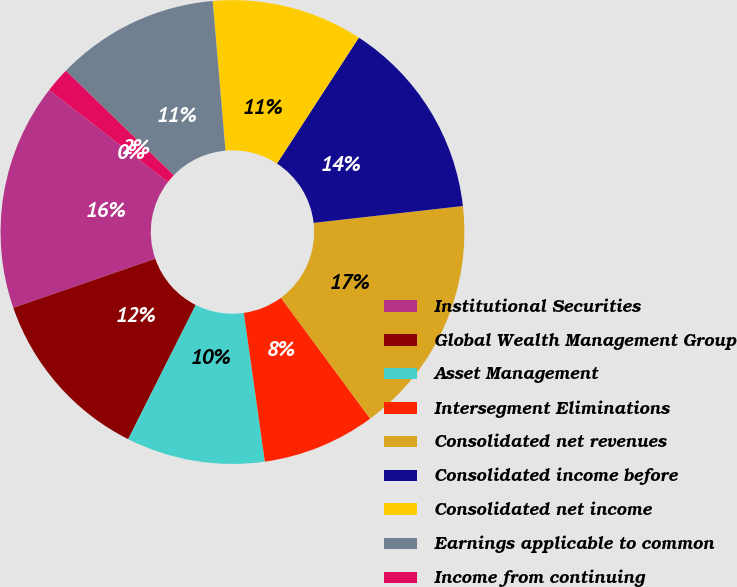<chart> <loc_0><loc_0><loc_500><loc_500><pie_chart><fcel>Institutional Securities<fcel>Global Wealth Management Group<fcel>Asset Management<fcel>Intersegment Eliminations<fcel>Consolidated net revenues<fcel>Consolidated income before<fcel>Consolidated net income<fcel>Earnings applicable to common<fcel>Income from continuing<fcel>Gain on discontinued<nl><fcel>15.79%<fcel>12.28%<fcel>9.65%<fcel>7.89%<fcel>16.67%<fcel>14.04%<fcel>10.53%<fcel>11.4%<fcel>1.75%<fcel>0.0%<nl></chart> 